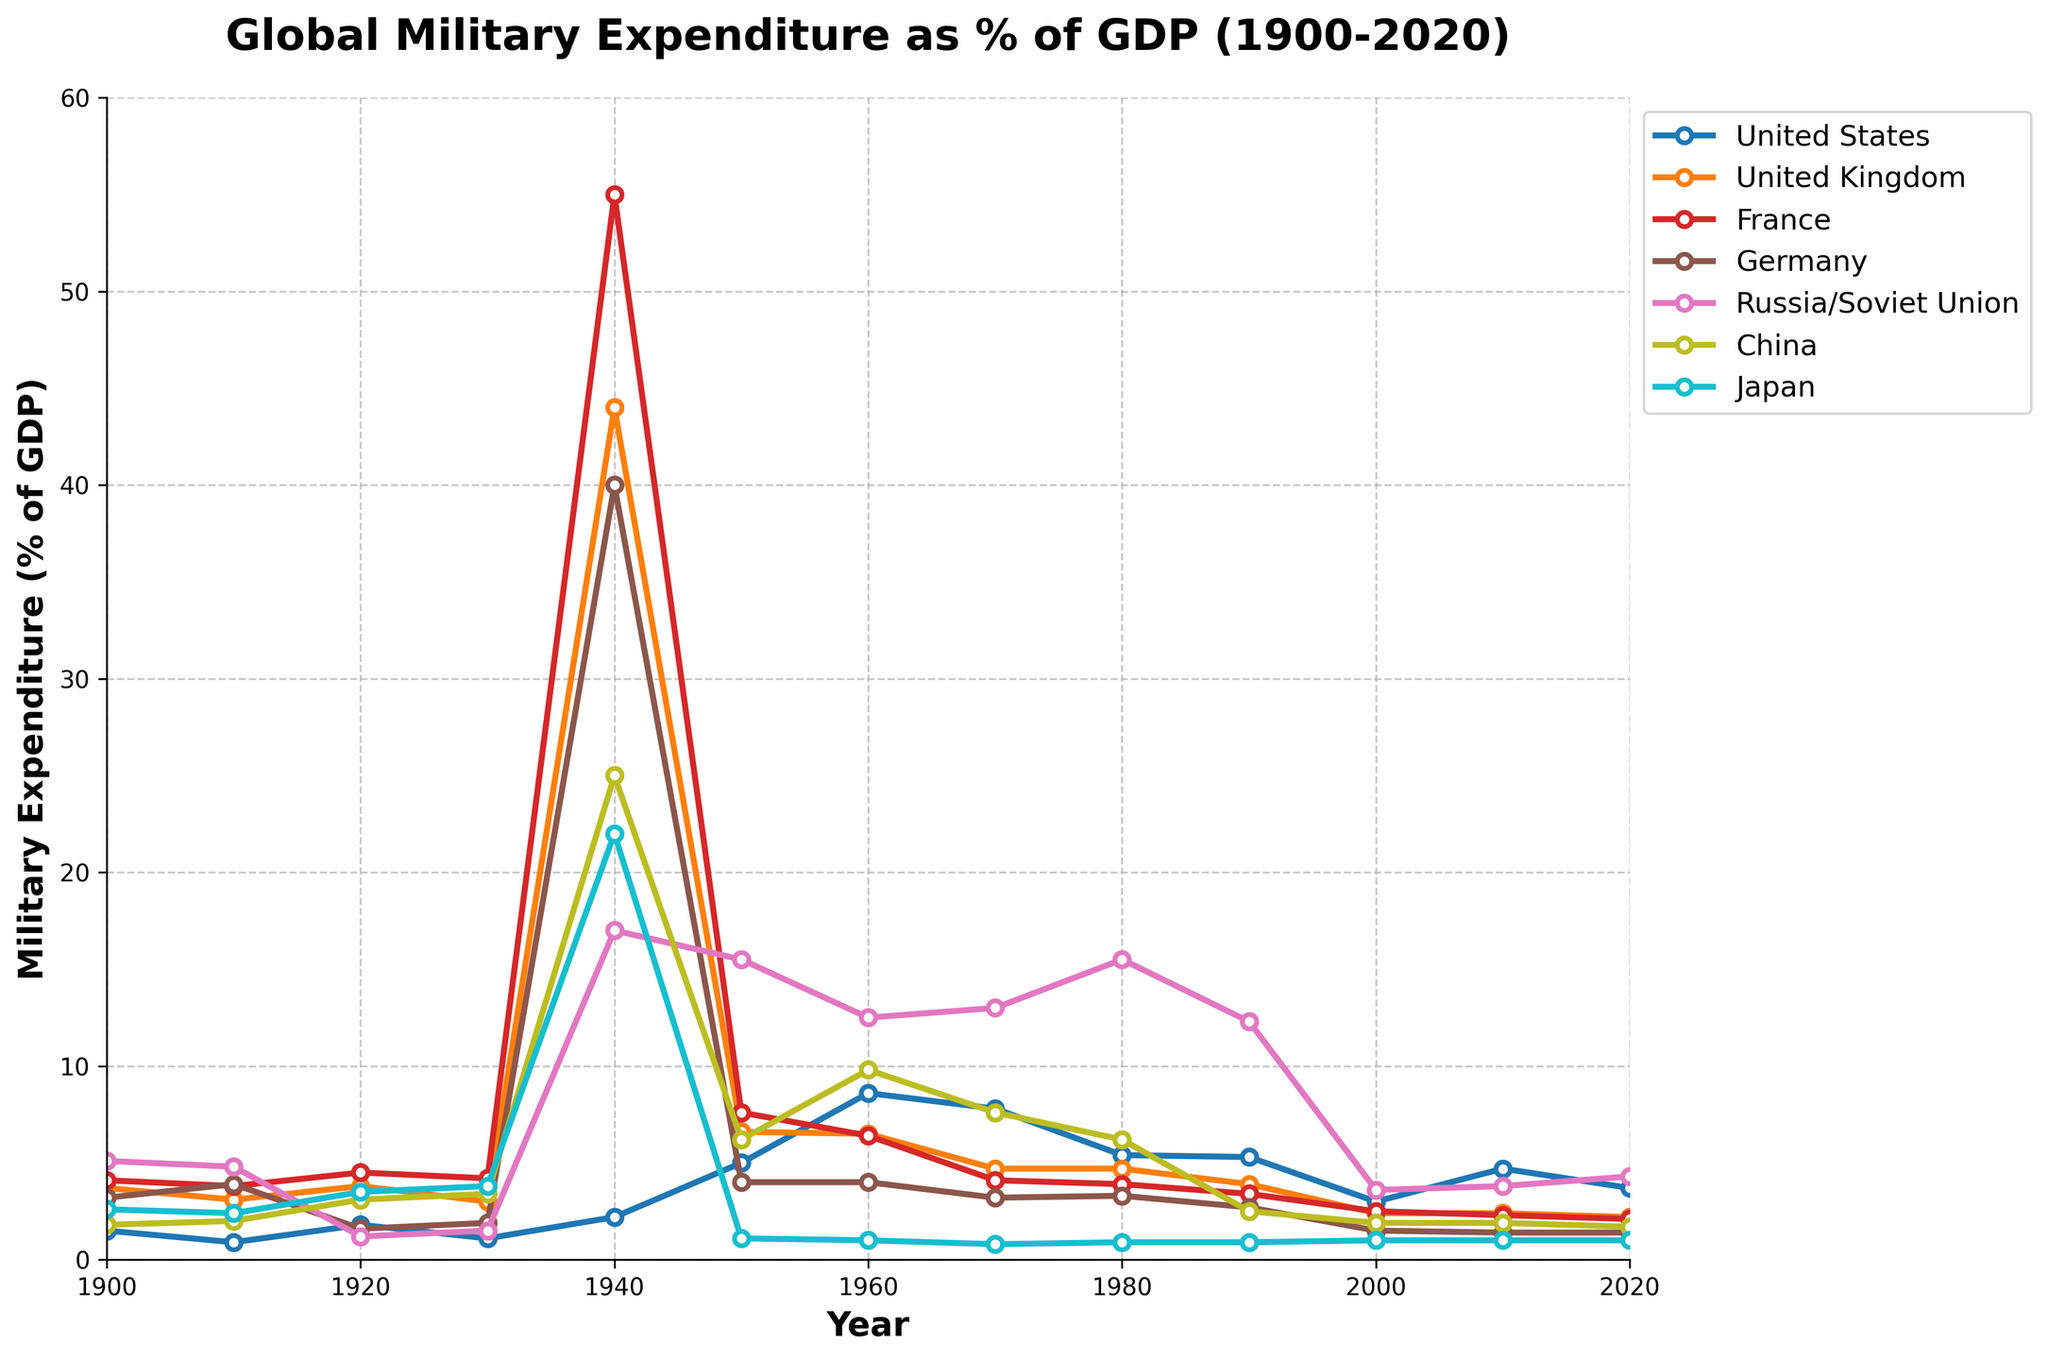What's the trend of military expenditure as a percentage of GDP for Japan from 1900 to 2020? In 1900, Japan's military expenditure was 2.6% of GDP. It remained relatively stable until 1930, increased sharply in 1940 to 22%, and then dropped to a low of around 1% from 1950 to 2020.
Answer: Decreasing Which country had the highest military expenditure as a percentage of GDP in 1940 and what was the value? In 1940, France had the highest military expenditure as a percentage of GDP with a value of 55%. This can be determined by observing the highest peak among the plotted lines for the year 1940.
Answer: France, 55% Compare the military expenditure of the United States and the Soviet Union in 1960. Which one was higher and by how much? In 1960, the United States had a military expenditure of 8.6% of GDP, whereas the Soviet Union had 12.5%. The Soviet Union's expenditure was higher by 3.9 percentage points.
Answer: The Soviet Union, 3.9% How did the military expenditure of China change from 1950 to 1970? In 1950, China's military expenditure was 6.2% of GDP. It increased to 9.8% in 1960 and then slightly decreased to 7.6% in 1970.
Answer: Increased then decreased Calculate the average military expenditure as a percentage of GDP for Russia/Soviet Union from 1900 to 2020. Add the given values (5.1, 4.8, 1.2, 1.5, 17.0, 15.5, 12.5, 13.0, 15.5, 12.3, 3.6, 3.8, 4.3) and divide by the number of data points (13): (5.1 + 4.8 + 1.2 + 1.5 + 17.0 + 15.5 + 12.5 + 13.0 + 15.5 + 12.3 + 3.6 + 3.8 + 4.3) / 13 = 8.46%
Answer: 8.46% In which decade did the United Kingdom see the most significant decrease in its military expenditure as a percentage of GDP, and what was the decrease? The UK saw the most significant decrease between the 1930s and 1940s, decreasing from around 3.0% to 44.0%.
Answer: 1930s to 1940s, 41% Compare the change in military expenditure percentages from 1900 to 2020 between Germany and France. Germany's expenditure went from 3.2% in 1900 to 1.4% in 2020, a decrease of 1.8 percentage points. France's expenditure went from 4.1% in 1900 to 2.1% in 2020, a decrease of 2 percentage points.
Answer: Germany decreased by 1.8%, France decreased by 2% Which country had the highest military expenditure as a percentage of GDP in 1950, and how does it compare to the United States in the same year? In 1950, the Soviet Union (Russia) had the highest military expenditure at 15.5%. The United States had 5.0%. The Soviet Union's expenditure was 10.5 percentage points higher than the United States.
Answer: Soviet Union, 15.5%, 10.5% higher Considering the entire time period, which country had the most stable military expenditure as a percentage of GDP? Japan had the most stable military expenditure, mostly remaining around 1% except for the spike in 1940. By visually assessing the plotted lines, Japan's line shows the least fluctuation compared to others.
Answer: Japan 